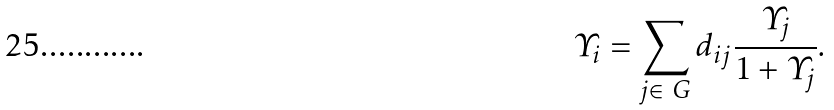<formula> <loc_0><loc_0><loc_500><loc_500>\varUpsilon _ { i } = \sum _ { j \in \ G } d _ { i j } \frac { \varUpsilon _ { j } } { 1 + \varUpsilon _ { j } } .</formula> 